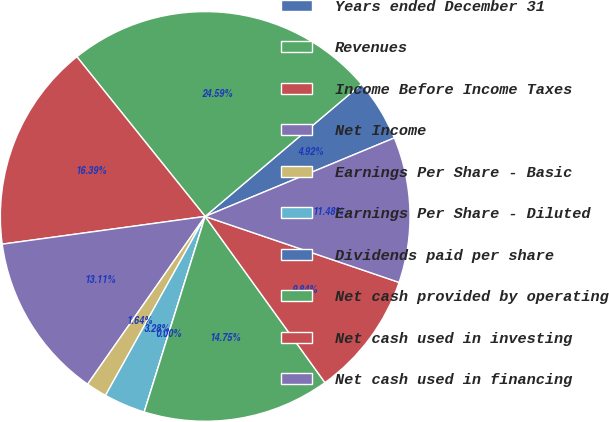<chart> <loc_0><loc_0><loc_500><loc_500><pie_chart><fcel>Years ended December 31<fcel>Revenues<fcel>Income Before Income Taxes<fcel>Net Income<fcel>Earnings Per Share - Basic<fcel>Earnings Per Share - Diluted<fcel>Dividends paid per share<fcel>Net cash provided by operating<fcel>Net cash used in investing<fcel>Net cash used in financing<nl><fcel>4.92%<fcel>24.59%<fcel>16.39%<fcel>13.11%<fcel>1.64%<fcel>3.28%<fcel>0.0%<fcel>14.75%<fcel>9.84%<fcel>11.48%<nl></chart> 